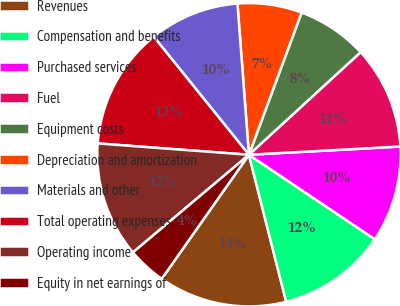<chart> <loc_0><loc_0><loc_500><loc_500><pie_chart><fcel>Revenues<fcel>Compensation and benefits<fcel>Purchased services<fcel>Fuel<fcel>Equipment costs<fcel>Depreciation and amortization<fcel>Materials and other<fcel>Total operating expenses<fcel>Operating income<fcel>Equity in net earnings of<nl><fcel>13.7%<fcel>11.64%<fcel>10.27%<fcel>10.96%<fcel>7.53%<fcel>6.85%<fcel>9.59%<fcel>13.01%<fcel>12.33%<fcel>4.11%<nl></chart> 